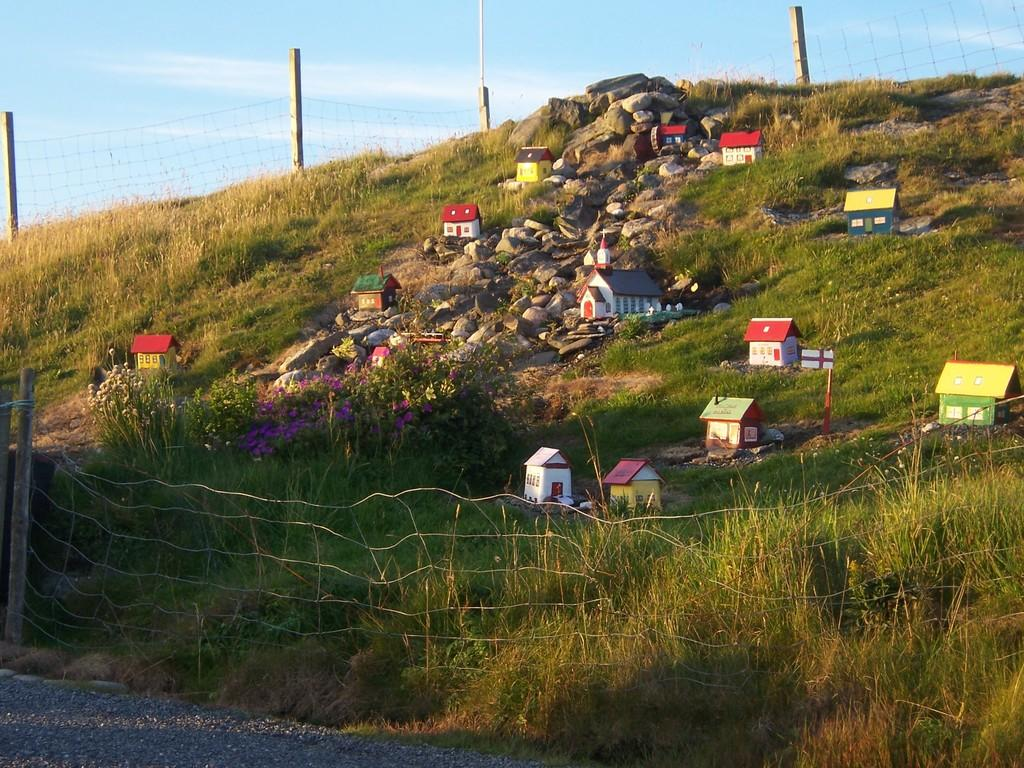What type of structures are shown in the image? There are houses depicted in the image. What type of vegetation can be seen in the image? There is grass visible in the image. What type of material is present in the image? Stones are present in the image. What type of barrier is in the image? There is fencing in the image. What type of pathway is at the bottom of the image? There is a road at the bottom of the image. What can be seen in the background of the image? The sky is visible in the background of the image. What direction is the wrench facing in the image? There is no wrench present in the image. What type of entrance is shown in the image? There is no gate present in the image. 